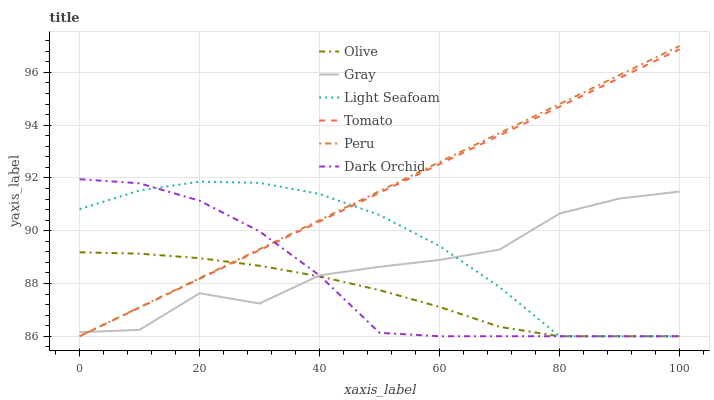Does Olive have the minimum area under the curve?
Answer yes or no. Yes. Does Peru have the maximum area under the curve?
Answer yes or no. Yes. Does Gray have the minimum area under the curve?
Answer yes or no. No. Does Gray have the maximum area under the curve?
Answer yes or no. No. Is Peru the smoothest?
Answer yes or no. Yes. Is Gray the roughest?
Answer yes or no. Yes. Is Dark Orchid the smoothest?
Answer yes or no. No. Is Dark Orchid the roughest?
Answer yes or no. No. Does Gray have the lowest value?
Answer yes or no. No. Does Peru have the highest value?
Answer yes or no. Yes. Does Gray have the highest value?
Answer yes or no. No. Does Olive intersect Dark Orchid?
Answer yes or no. Yes. Is Olive less than Dark Orchid?
Answer yes or no. No. Is Olive greater than Dark Orchid?
Answer yes or no. No. 